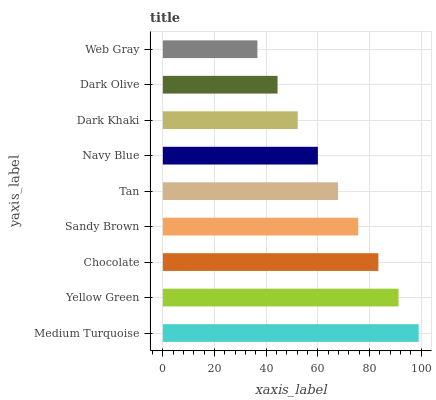Is Web Gray the minimum?
Answer yes or no. Yes. Is Medium Turquoise the maximum?
Answer yes or no. Yes. Is Yellow Green the minimum?
Answer yes or no. No. Is Yellow Green the maximum?
Answer yes or no. No. Is Medium Turquoise greater than Yellow Green?
Answer yes or no. Yes. Is Yellow Green less than Medium Turquoise?
Answer yes or no. Yes. Is Yellow Green greater than Medium Turquoise?
Answer yes or no. No. Is Medium Turquoise less than Yellow Green?
Answer yes or no. No. Is Tan the high median?
Answer yes or no. Yes. Is Tan the low median?
Answer yes or no. Yes. Is Sandy Brown the high median?
Answer yes or no. No. Is Chocolate the low median?
Answer yes or no. No. 